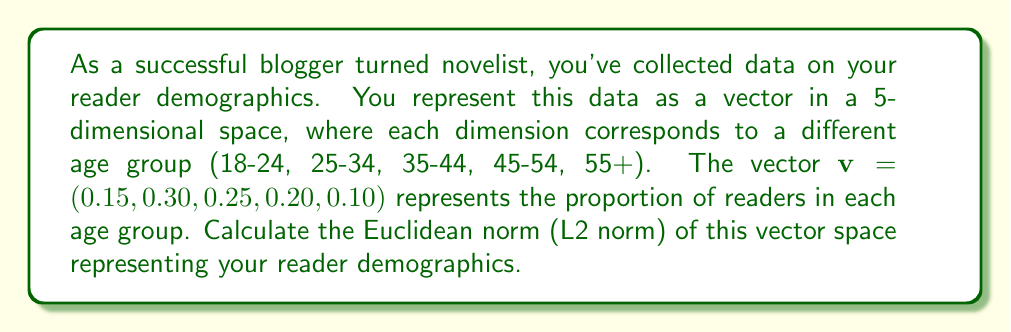Solve this math problem. To calculate the Euclidean norm (L2 norm) of the vector $v = (0.15, 0.30, 0.25, 0.20, 0.10)$, we follow these steps:

1) The Euclidean norm of a vector $v = (v_1, v_2, ..., v_n)$ is defined as:

   $$\|v\|_2 = \sqrt{\sum_{i=1}^n |v_i|^2}$$

2) In our case, we have:
   
   $$\|v\|_2 = \sqrt{(0.15)^2 + (0.30)^2 + (0.25)^2 + (0.20)^2 + (0.10)^2}$$

3) Let's calculate each term:
   
   $(0.15)^2 = 0.0225$
   $(0.30)^2 = 0.0900$
   $(0.25)^2 = 0.0625$
   $(0.20)^2 = 0.0400$
   $(0.10)^2 = 0.0100$

4) Sum these terms:

   $$0.0225 + 0.0900 + 0.0625 + 0.0400 + 0.0100 = 0.2250$$

5) Take the square root of this sum:

   $$\sqrt{0.2250} \approx 0.4743$$

Therefore, the Euclidean norm of the vector representing reader demographics is approximately 0.4743.
Answer: $\|v\|_2 \approx 0.4743$ 